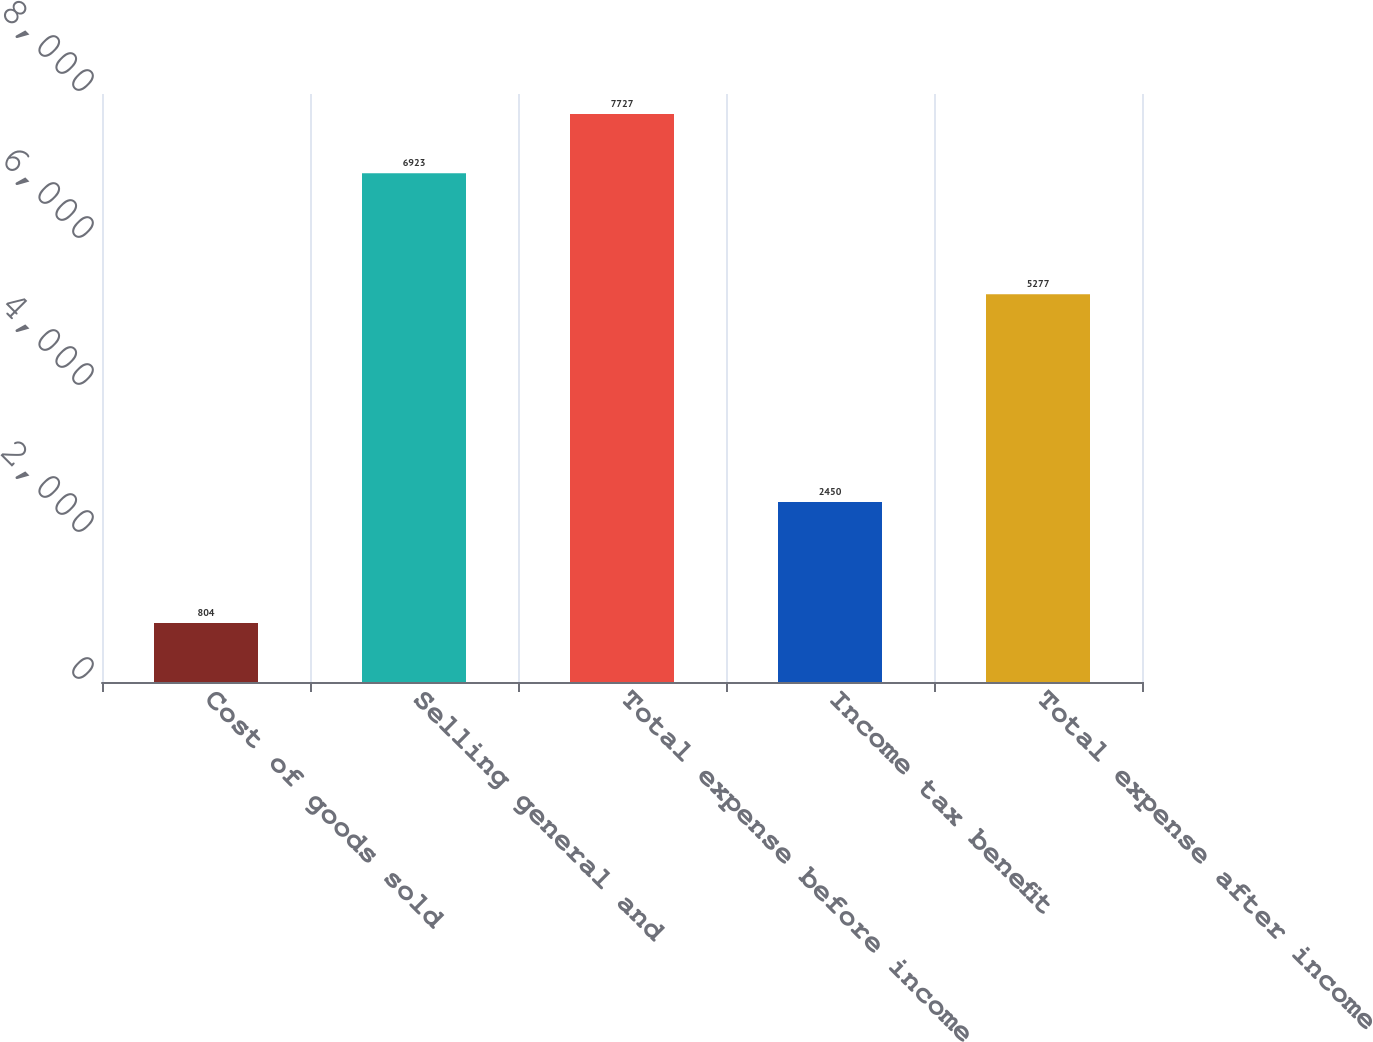<chart> <loc_0><loc_0><loc_500><loc_500><bar_chart><fcel>Cost of goods sold<fcel>Selling general and<fcel>Total expense before income<fcel>Income tax benefit<fcel>Total expense after income<nl><fcel>804<fcel>6923<fcel>7727<fcel>2450<fcel>5277<nl></chart> 